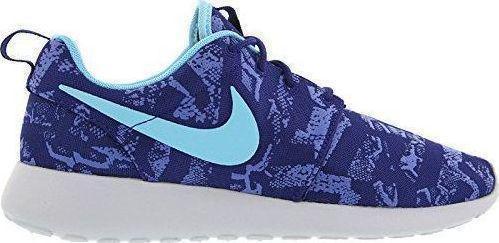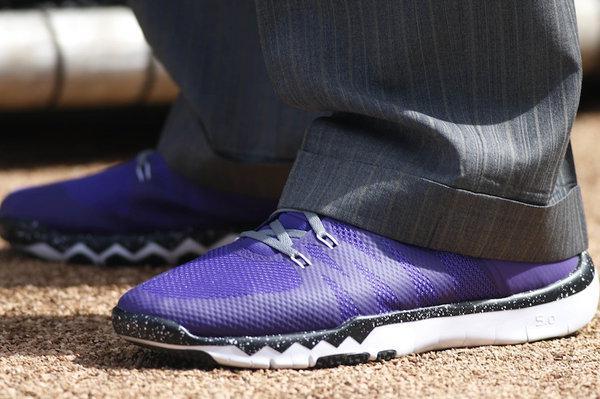The first image is the image on the left, the second image is the image on the right. For the images displayed, is the sentence "In one image, at least one shoe is being worn by a human." factually correct? Answer yes or no. Yes. 